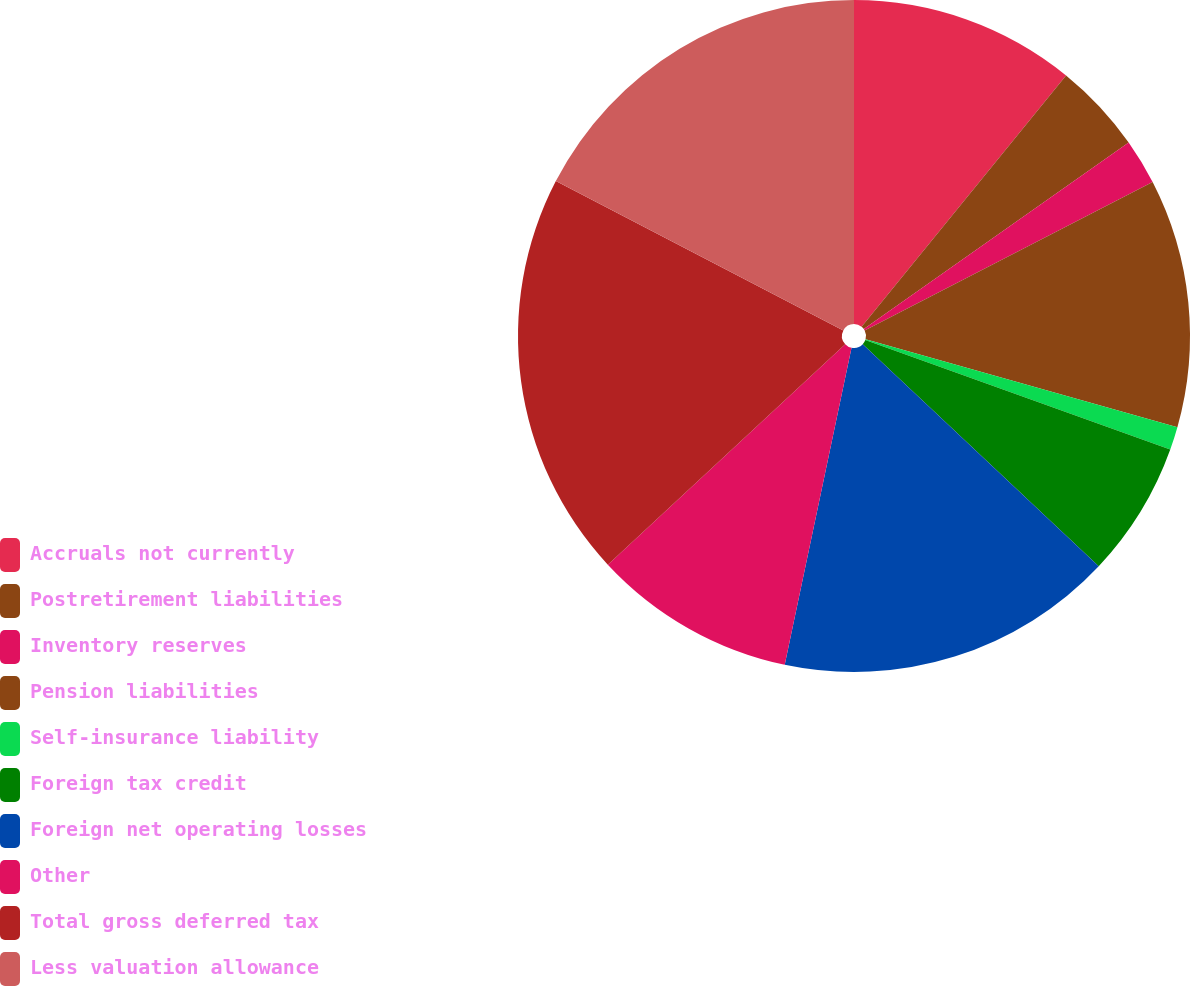<chart> <loc_0><loc_0><loc_500><loc_500><pie_chart><fcel>Accruals not currently<fcel>Postretirement liabilities<fcel>Inventory reserves<fcel>Pension liabilities<fcel>Self-insurance liability<fcel>Foreign tax credit<fcel>Foreign net operating losses<fcel>Other<fcel>Total gross deferred tax<fcel>Less valuation allowance<nl><fcel>10.87%<fcel>4.36%<fcel>2.19%<fcel>11.95%<fcel>1.11%<fcel>6.53%<fcel>16.29%<fcel>9.78%<fcel>19.54%<fcel>17.37%<nl></chart> 